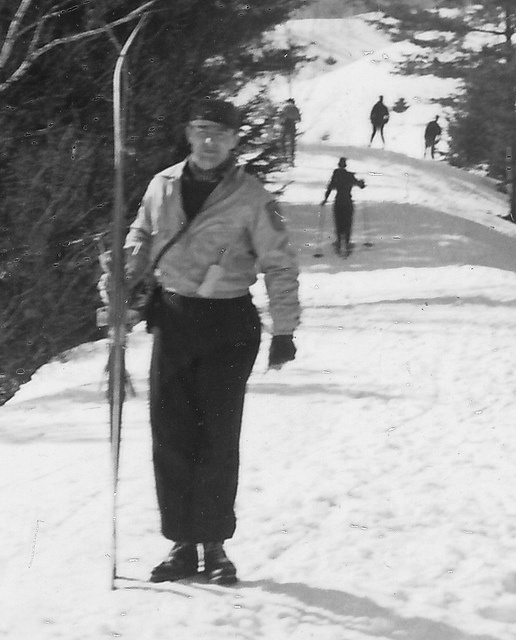Describe the objects in this image and their specific colors. I can see people in black, gray, and lightgray tones, skis in black, gray, darkgray, and lightgray tones, people in black, gray, lightgray, and darkgray tones, handbag in black, gray, and lightgray tones, and people in black, gray, darkgray, and lightgray tones in this image. 